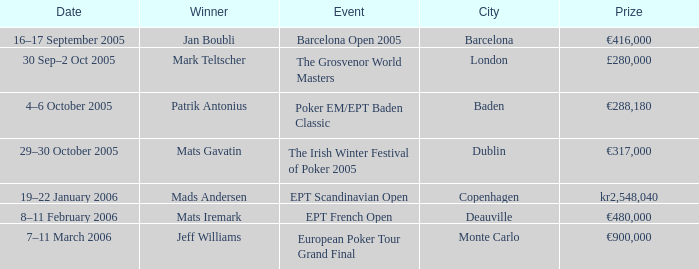What event had a prize of €900,000? European Poker Tour Grand Final. 